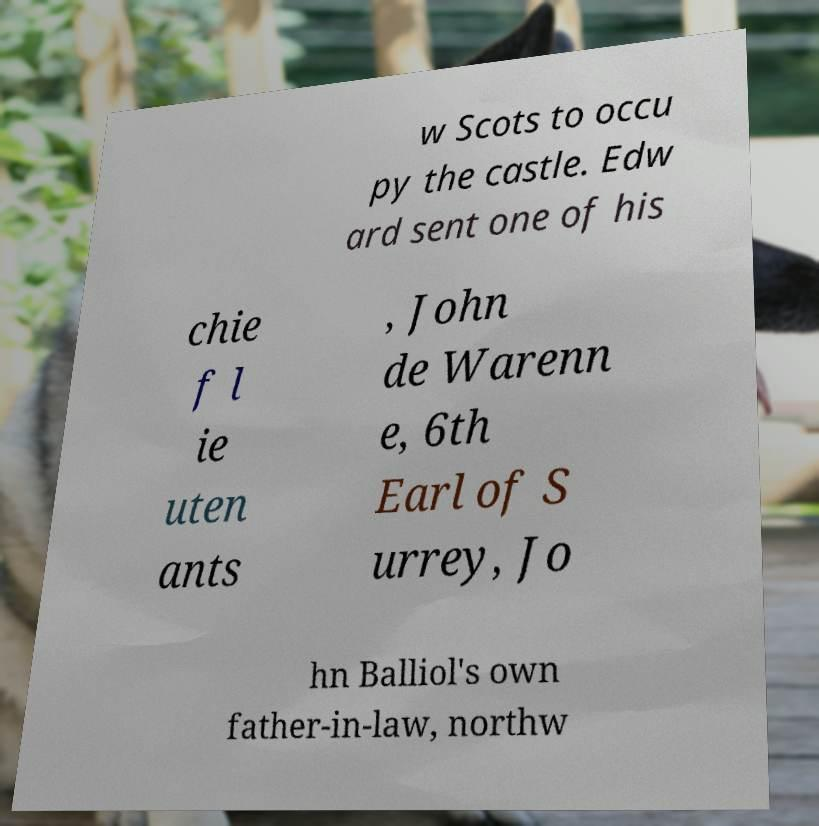What messages or text are displayed in this image? I need them in a readable, typed format. w Scots to occu py the castle. Edw ard sent one of his chie f l ie uten ants , John de Warenn e, 6th Earl of S urrey, Jo hn Balliol's own father-in-law, northw 